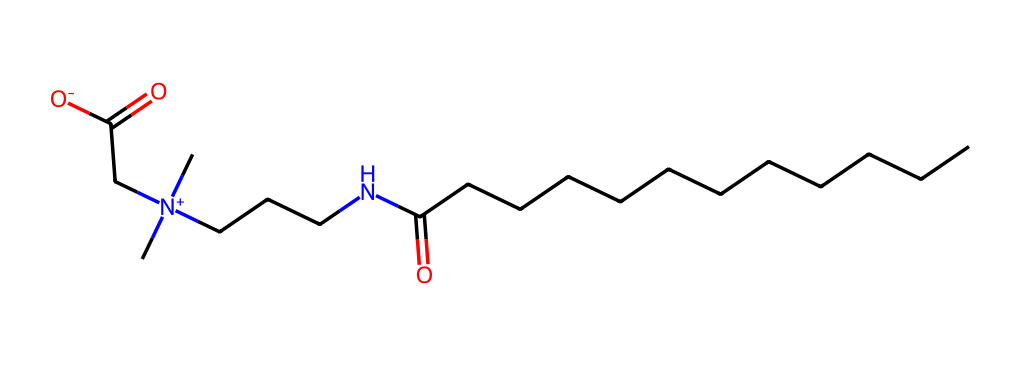what is the molecular formula of cocamidopropyl betaine? The SMILES representation shows various elements and their counts. Analyzing the structure reveals 13 carbon (C), 25 hydrogen (H), 1 nitrogen (N), and 2 oxygen (O) atoms. Therefore, the molecular formula is C13H25N2O2.
Answer: C13H25N2O2 how many carbon atoms are present in cocamidopropyl betaine? By counting the 'C' symbols in the SMILES, we identify there are 13 carbon atoms in the structure.
Answer: 13 what type of bonding predominates in cocamidopropyl betaine? The structure involves covalent bonding, characterized by the sharing of electrons between atoms, which is common in organic molecules. The presence of carbon bonds indicates this strongly.
Answer: covalent which functional groups are present in cocamidopropyl betaine? The structure shows both a carboxylic acid (-COOH) group and a quaternary ammonium ion (due to the positively charged nitrogen), making these two essential functional groups in the molecule.
Answer: carboxylic acid and quaternary ammonium what role does the quaternary ammonium group play in surfactants like cocamidopropyl betaine? The quaternary ammonium group enhances surface activity, reducing surface tension in water, which is crucial for the surfactant property in cleaning and foaming applications.
Answer: enhances surface activity how many nitrogen atoms are found in cocamidopropyl betaine? The structure indicates there are two nitrogen atoms (N) present, as shown in the SMILES representation.
Answer: 2 why is cocamidopropyl betaine considered an amphoteric surfactant? The presence of both a positively charged quaternary ammonium group and a negatively charged carboxylate group allows it to behave as either an acid or a base, characteristic of amphoteric surfactants.
Answer: amphoteric 